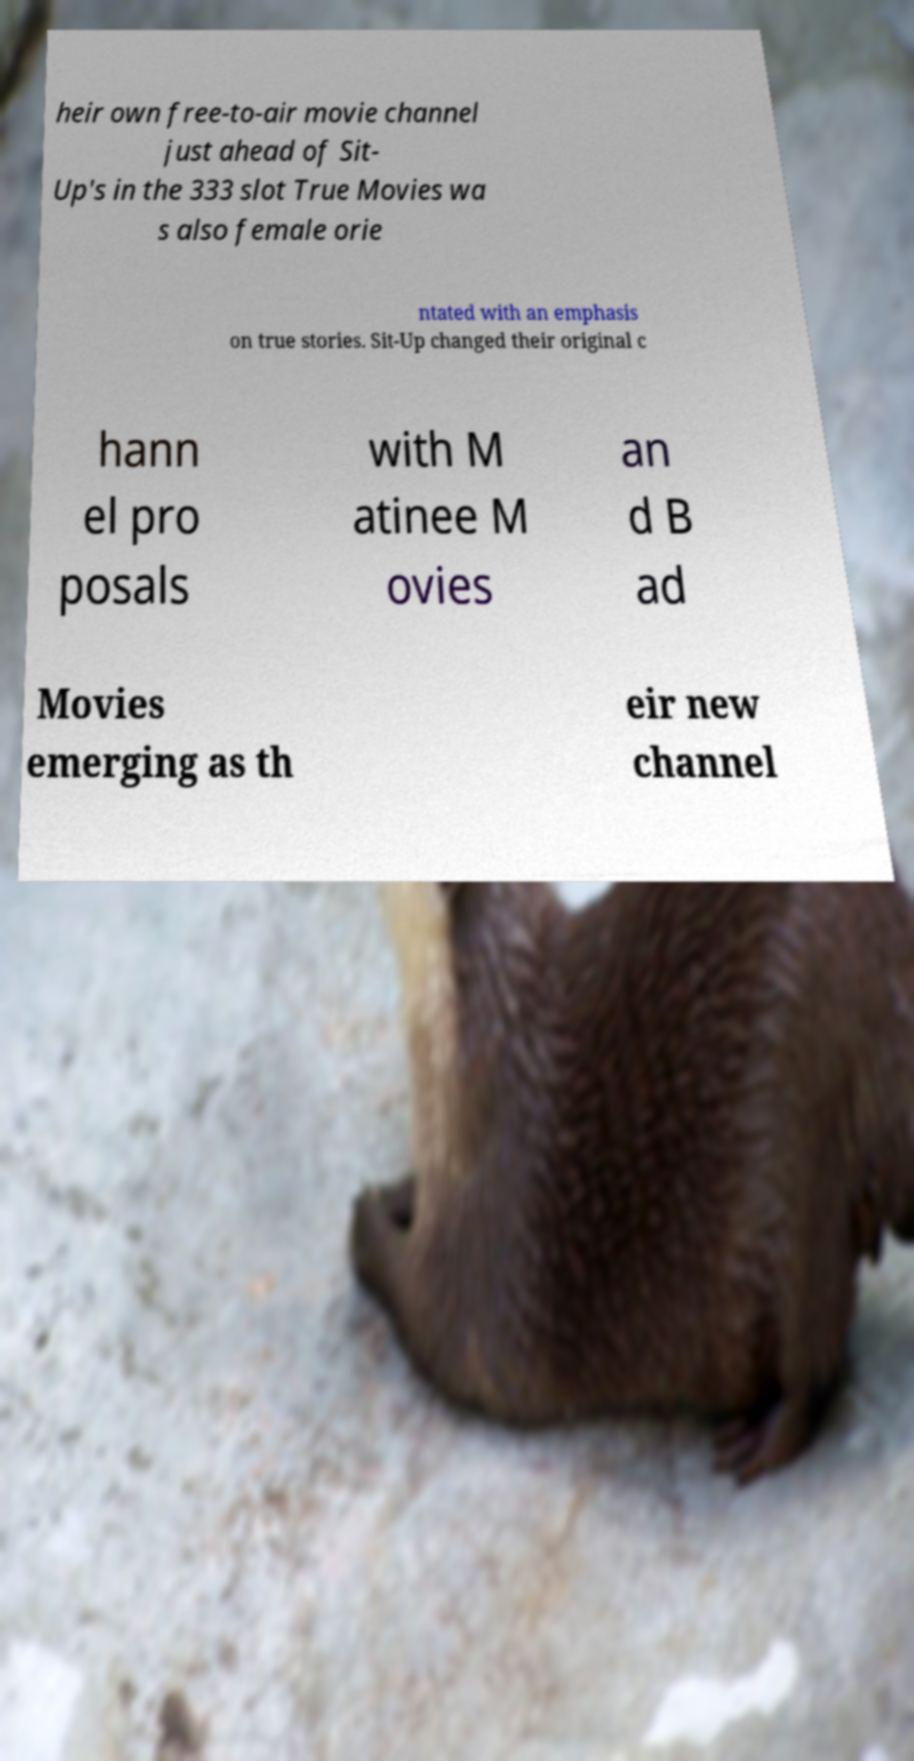Can you accurately transcribe the text from the provided image for me? heir own free-to-air movie channel just ahead of Sit- Up's in the 333 slot True Movies wa s also female orie ntated with an emphasis on true stories. Sit-Up changed their original c hann el pro posals with M atinee M ovies an d B ad Movies emerging as th eir new channel 